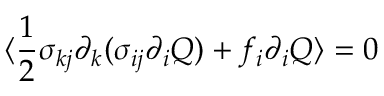Convert formula to latex. <formula><loc_0><loc_0><loc_500><loc_500>\langle \frac { 1 } { 2 } \sigma _ { k j } \partial _ { k } ( \sigma _ { i j } \partial _ { i } Q ) + f _ { i } \partial _ { i } Q \rangle = 0</formula> 